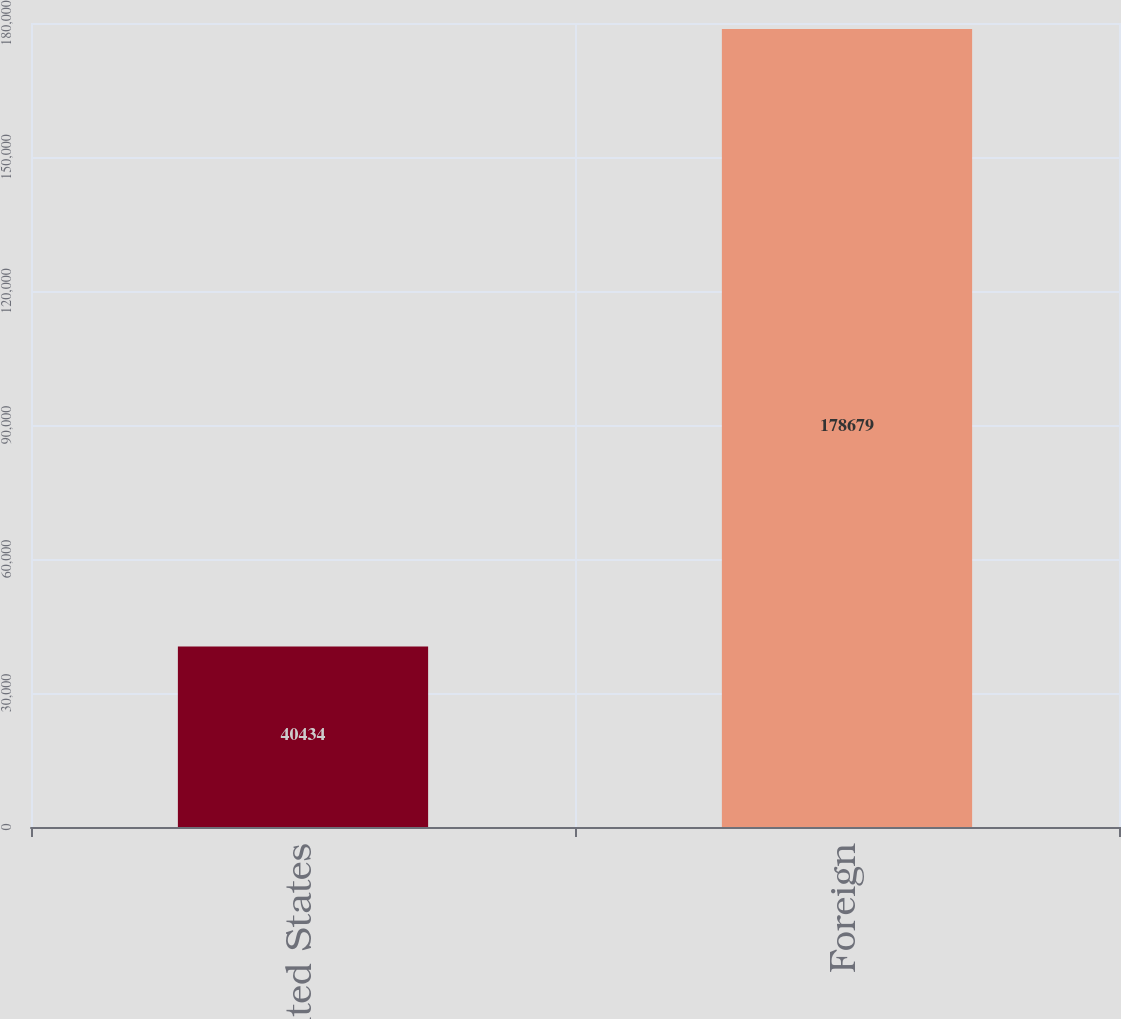<chart> <loc_0><loc_0><loc_500><loc_500><bar_chart><fcel>United States<fcel>Foreign<nl><fcel>40434<fcel>178679<nl></chart> 